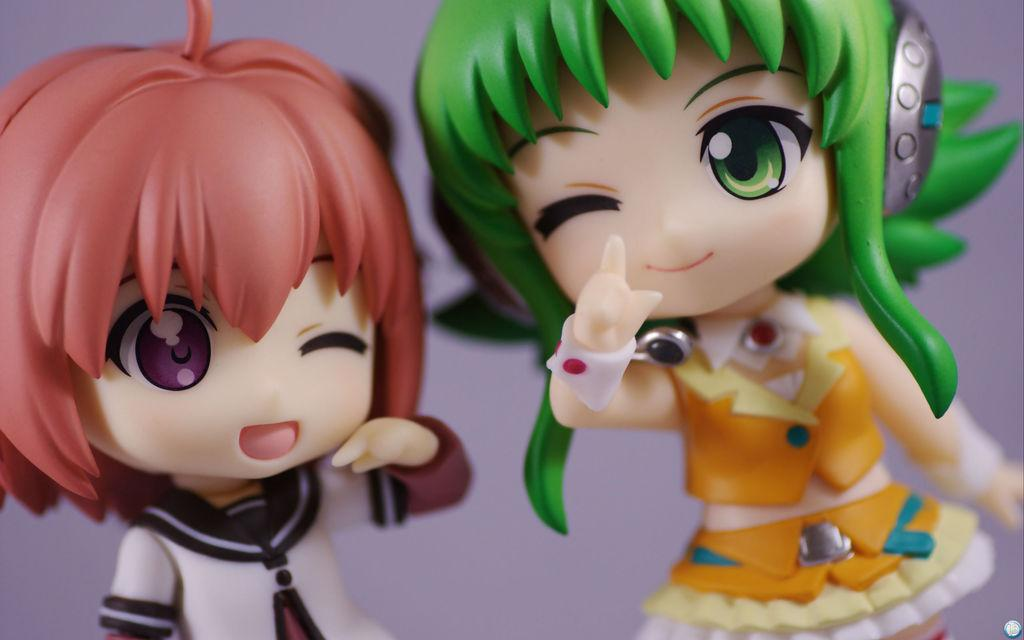What objects are present in the image? There are toys in the image. Who do the toys belong to? The toys belong to girls. What is the color of the background in the image? The background color appears to be light purple. What type of music can be heard playing in the background of the image? There is no music present in the image, as it is a still image of toys and does not contain any audible elements. 